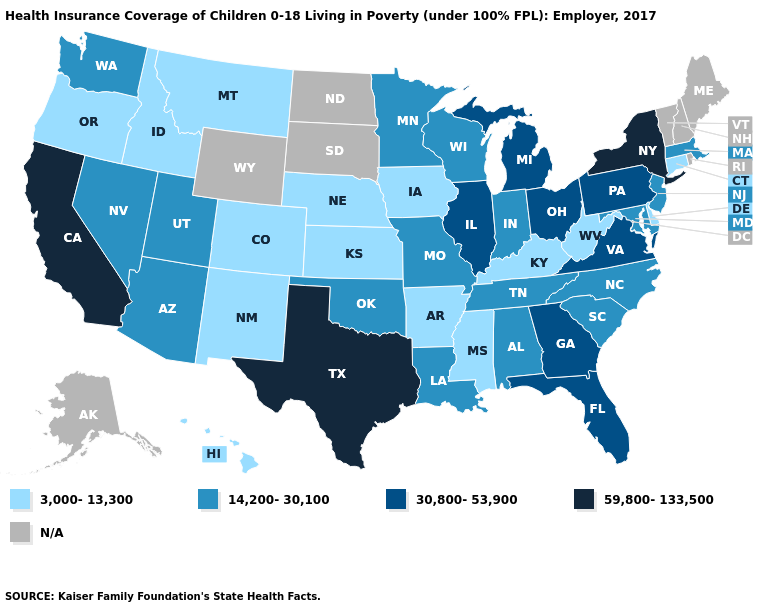What is the value of Kentucky?
Keep it brief. 3,000-13,300. What is the value of Utah?
Keep it brief. 14,200-30,100. Which states have the lowest value in the MidWest?
Keep it brief. Iowa, Kansas, Nebraska. Name the states that have a value in the range 59,800-133,500?
Short answer required. California, New York, Texas. What is the value of Louisiana?
Answer briefly. 14,200-30,100. Does Texas have the highest value in the South?
Give a very brief answer. Yes. What is the value of Kentucky?
Concise answer only. 3,000-13,300. What is the value of Virginia?
Concise answer only. 30,800-53,900. Name the states that have a value in the range 59,800-133,500?
Write a very short answer. California, New York, Texas. Among the states that border Delaware , which have the lowest value?
Quick response, please. Maryland, New Jersey. Name the states that have a value in the range 14,200-30,100?
Write a very short answer. Alabama, Arizona, Indiana, Louisiana, Maryland, Massachusetts, Minnesota, Missouri, Nevada, New Jersey, North Carolina, Oklahoma, South Carolina, Tennessee, Utah, Washington, Wisconsin. What is the lowest value in the USA?
Be succinct. 3,000-13,300. 